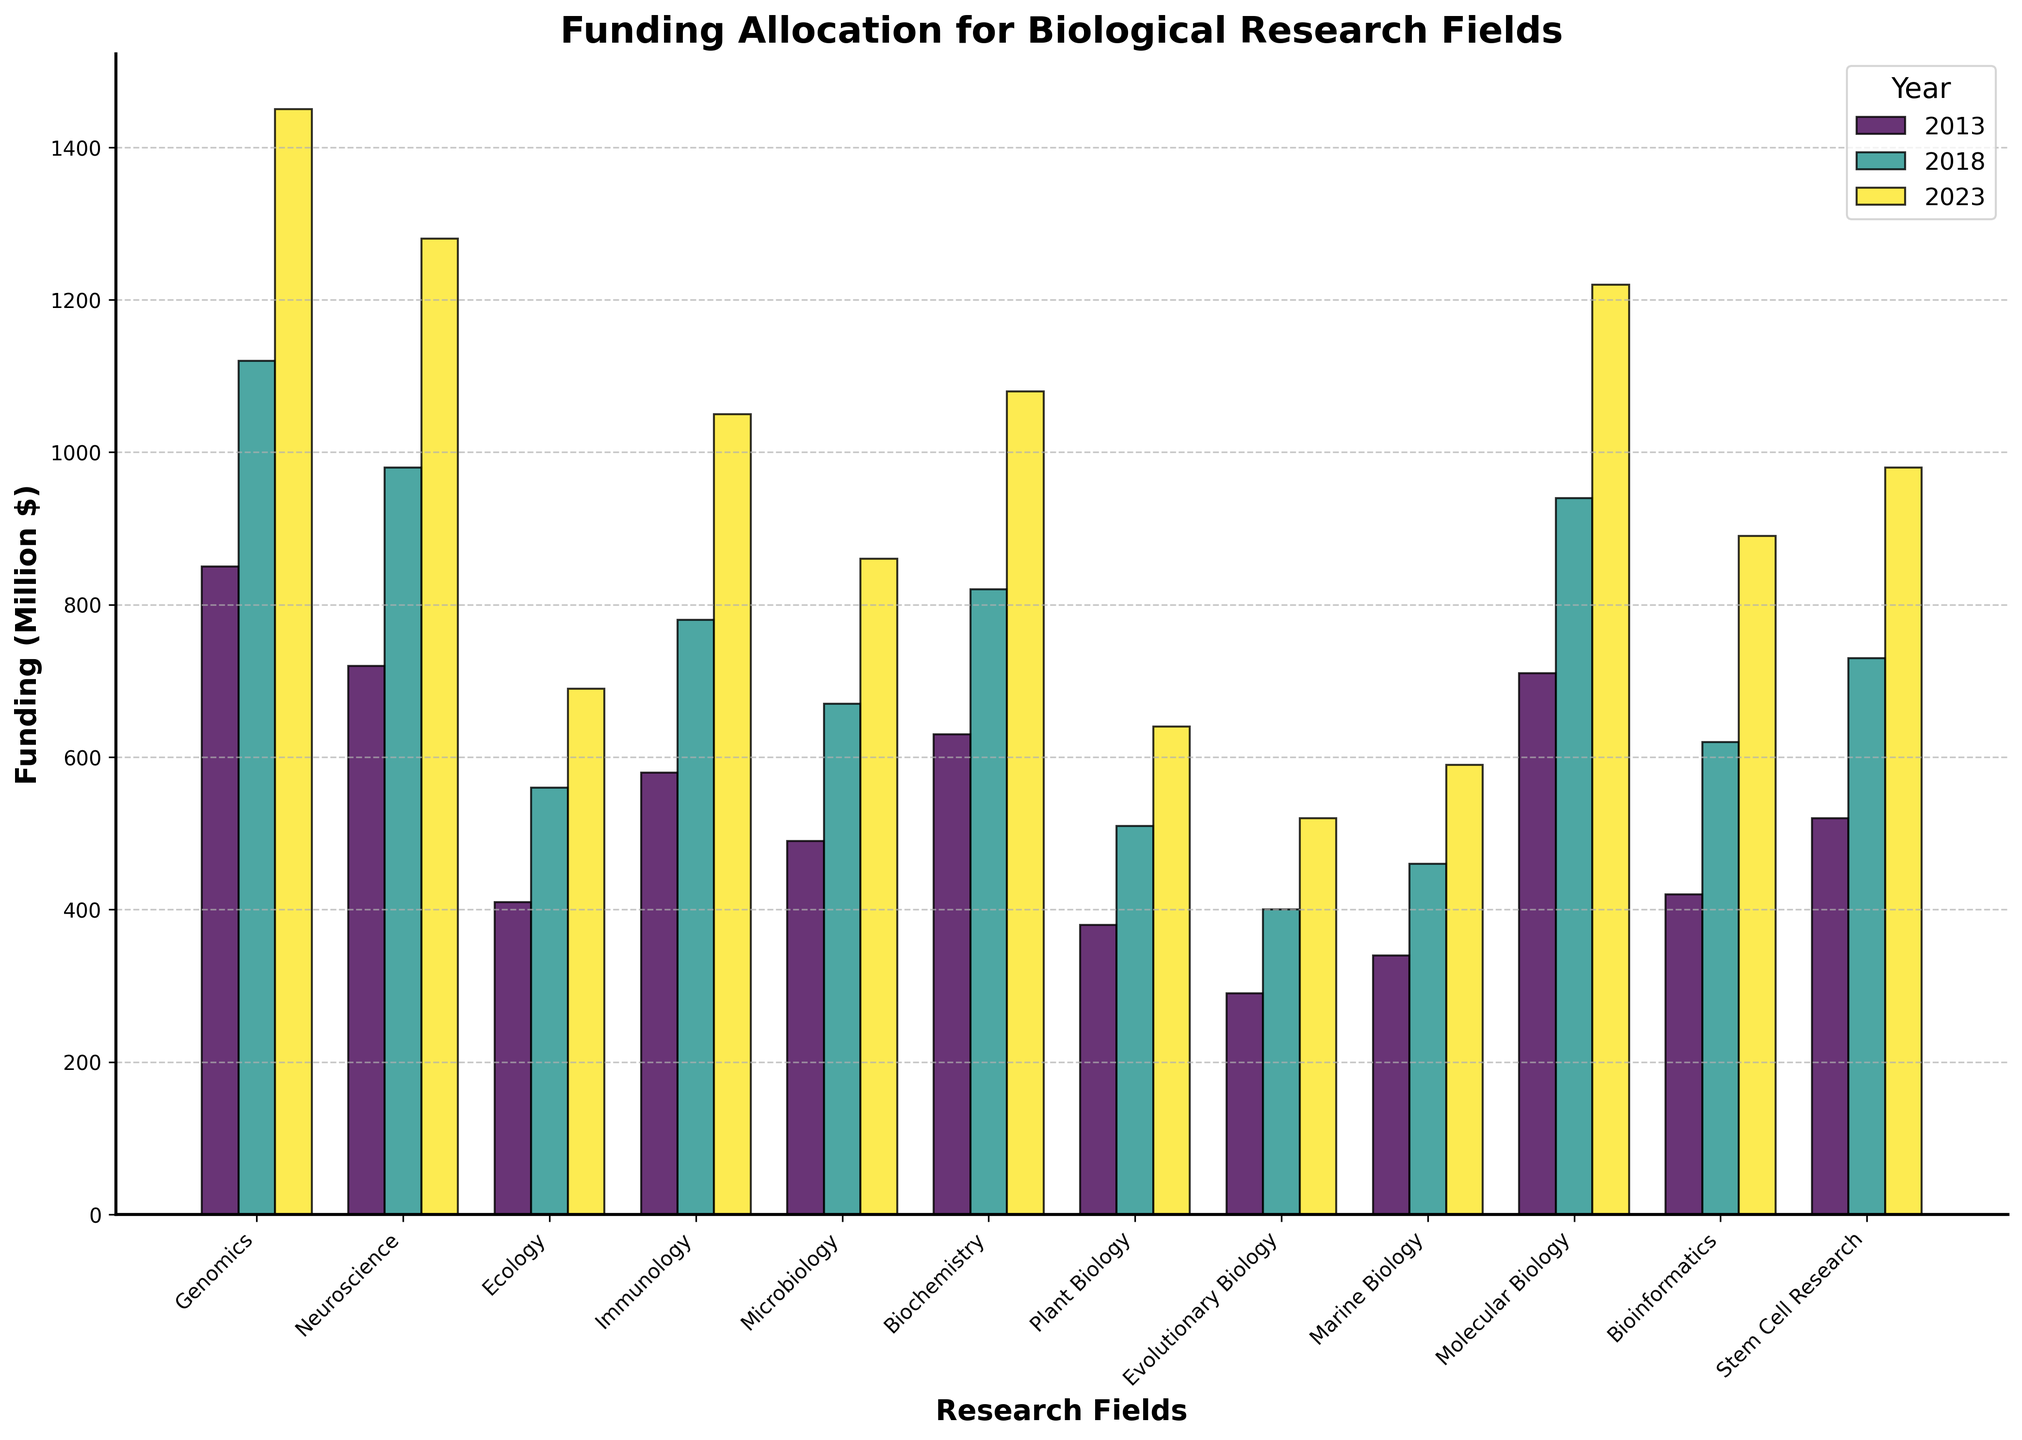Which research field received the highest funding in 2023? Observe the height of the bars for 2023. The tallest bar is for Genomics.
Answer: Genomics Compare the funding for Neuroscience and Molecular Biology in 2018. Which one is higher? Look at the bars for Neuroscience and Molecular Biology in 2018. The Molecular Biology bar is slightly higher.
Answer: Molecular Biology What is the total funding for Immunology over the three years shown? Sum the heights of the bars for Immunology for 2013, 2018, and 2023: 580 + 780 + 1050.
Answer: 2410 How has funding for Plant Biology changed from 2013 to 2023? Compare the bars for Plant Biology in 2013 and 2023 to see the increase or decrease in funding. Plant Biology increased from 380 to 640.
Answer: Increased What is the difference in funding between Genomics and Ecology in 2023? Subtract the height of the Ecology bar from the height of the Genomics bar in 2023: 1450 - 690.
Answer: 760 Which research field had the smallest increase in funding from 2013 to 2023? Calculate the difference between 2023 and 2013 for each field. Evolutionary Biology increased the least from 290 to 520, an increase of 230.
Answer: Evolutionary Biology What is the average funding for Biochemistry across the three years? Add the funding amounts for 2013, 2018, and 2023 for Biochemistry, then divide by 3: (630 + 820 + 1080) / 3.
Answer: 843.33 Compare the funding for Microbiology and Marine Biology in 2013. Which one received more funding? Observe the heights of the bars for Microbiology and Marine Biology in 2013. Microbiology is higher.
Answer: Microbiology What is the cumulative funding for all research fields in 2023? Sum the funding for all research fields in 2023: 1450 + 1280 + 690 + 1050 + 860 + 1080 + 640 + 520 + 590 + 1220 + 890 + 980.
Answer: 12250 Which research field had the most substantial percentage increase in funding from 2013 to 2023? Calculate the percentage increase for each field [(2023 funding - 2013 funding) / 2013 funding * 100] and determine the highest. Bioinformatics increased from 420 to 890, which is ((890-420)/420) * 100 = 111.90%.
Answer: Bioinformatics 